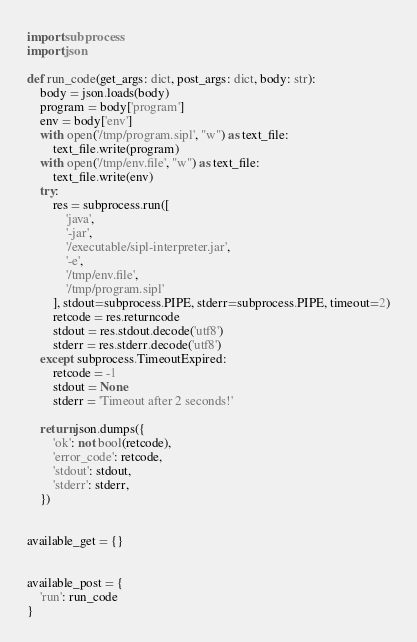Convert code to text. <code><loc_0><loc_0><loc_500><loc_500><_Python_>import subprocess
import json

def run_code(get_args: dict, post_args: dict, body: str):
    body = json.loads(body)
    program = body['program']
    env = body['env']
    with open('/tmp/program.sipl', "w") as text_file:
        text_file.write(program)
    with open('/tmp/env.file', "w") as text_file:
        text_file.write(env)
    try:
        res = subprocess.run([
            'java',
            '-jar',
            '/executable/sipl-interpreter.jar',
            '-e',
            '/tmp/env.file',
            '/tmp/program.sipl'
        ], stdout=subprocess.PIPE, stderr=subprocess.PIPE, timeout=2)
        retcode = res.returncode
        stdout = res.stdout.decode('utf8')
        stderr = res.stderr.decode('utf8')
    except subprocess.TimeoutExpired:
        retcode = -1
        stdout = None
        stderr = 'Timeout after 2 seconds!'

    return json.dumps({
        'ok': not bool(retcode),
        'error_code': retcode,
        'stdout': stdout,
        'stderr': stderr,
    })


available_get = {}


available_post = {
    'run': run_code
}
</code> 